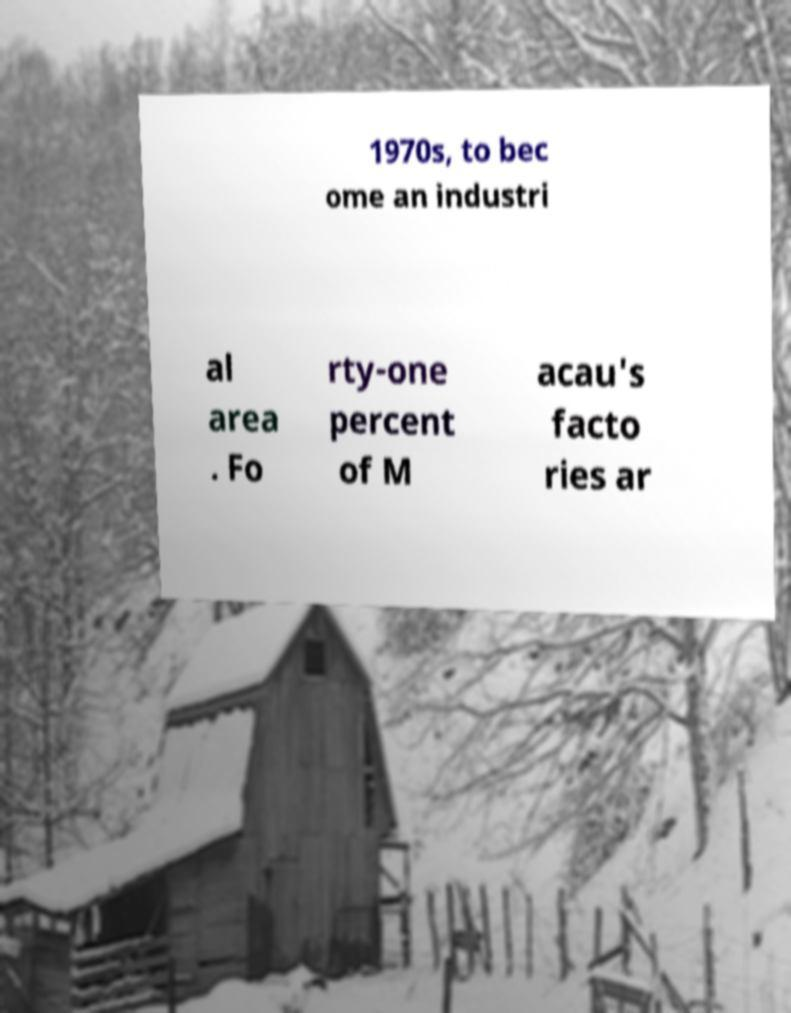What messages or text are displayed in this image? I need them in a readable, typed format. 1970s, to bec ome an industri al area . Fo rty-one percent of M acau's facto ries ar 